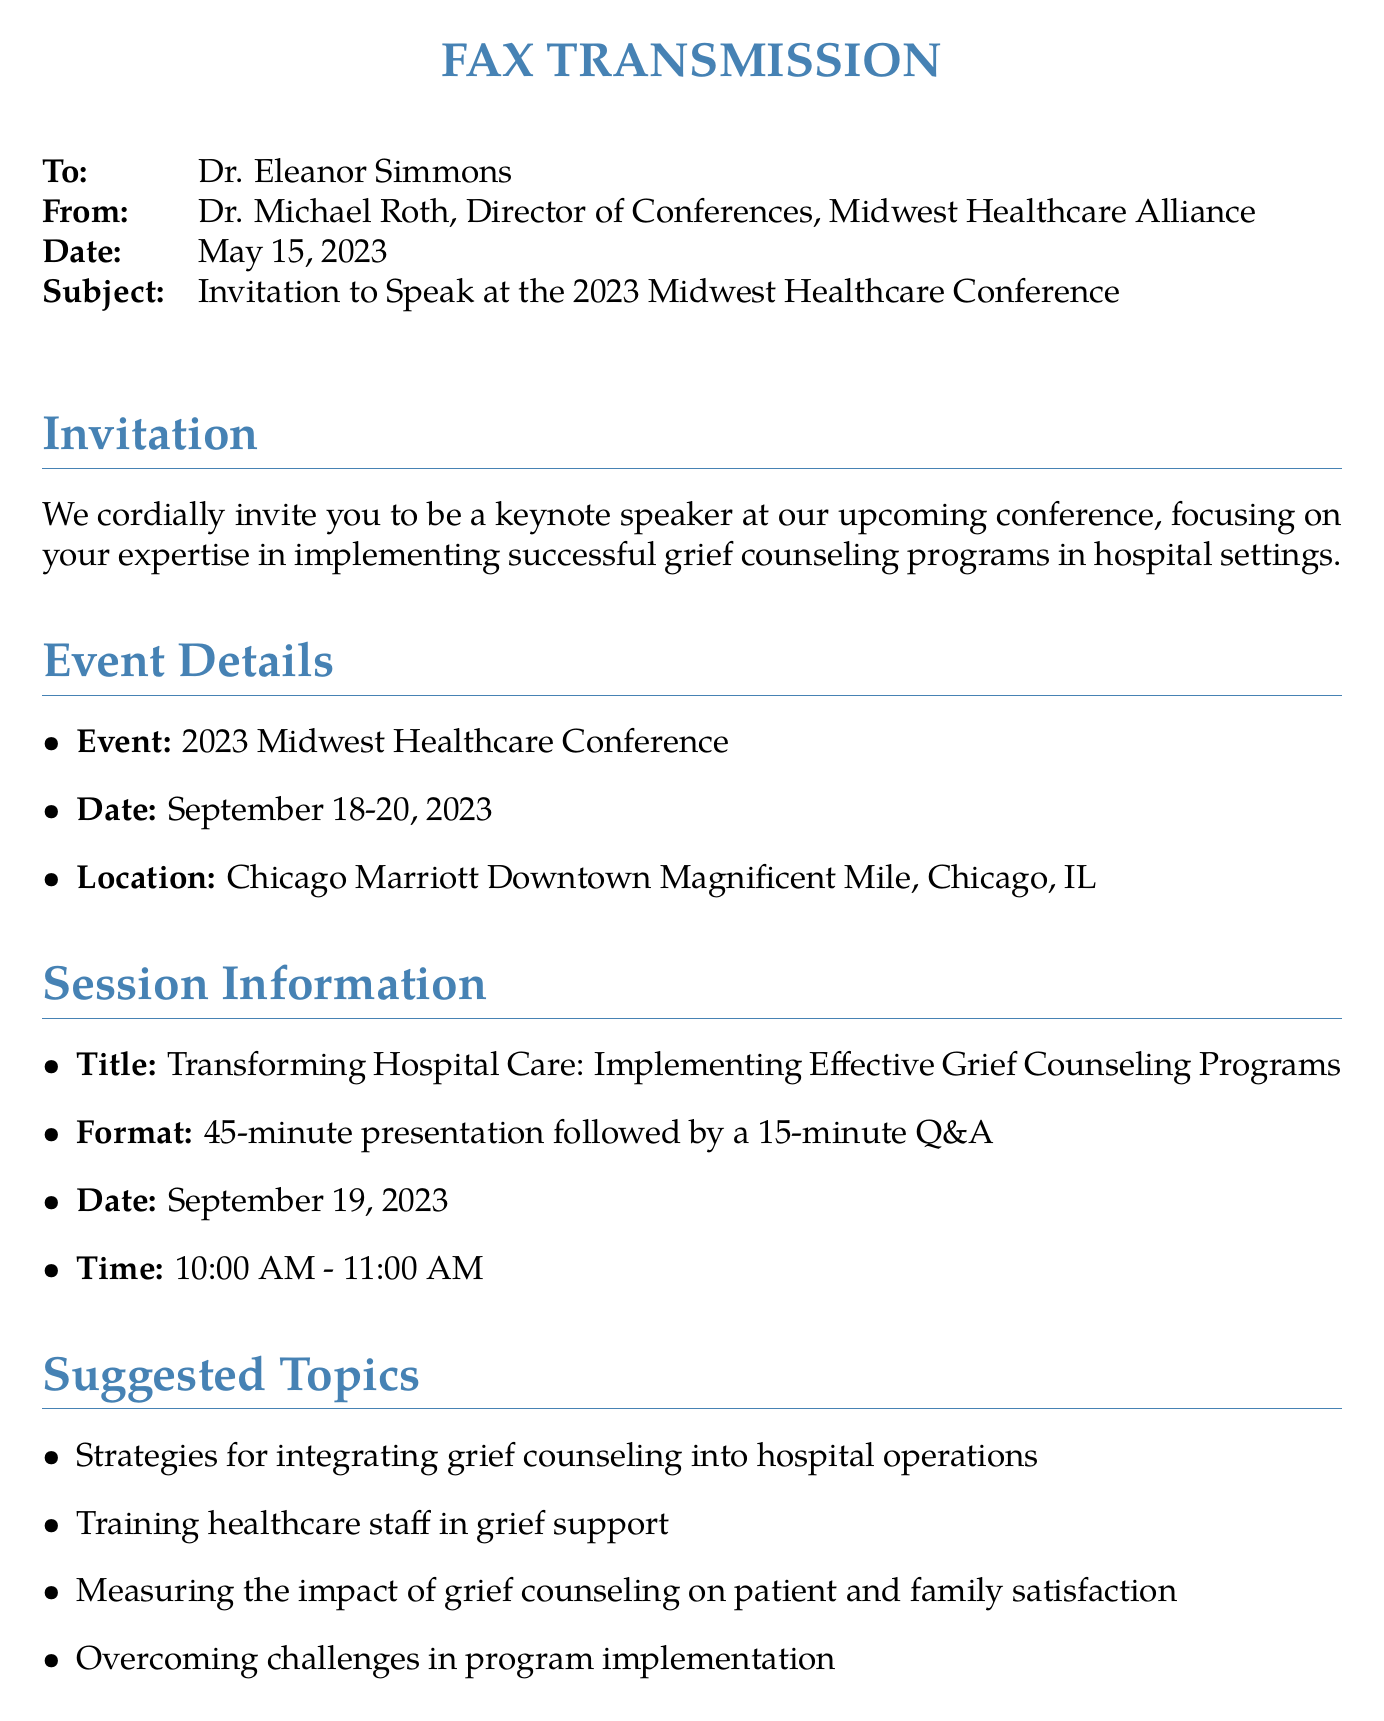What is the name of the conference? The conference is specified in the subject line of the fax as the "2023 Midwest Healthcare Conference."
Answer: 2023 Midwest Healthcare Conference Who is the invitee to the conference? The "To" section of the fax clearly states that Dr. Eleanor Simmons is the invitee.
Answer: Dr. Eleanor Simmons What are the conference dates? The date of the conference is mentioned in the event details section as September 18-20, 2023.
Answer: September 18-20, 2023 What is the title of the keynote presentation? The presentation title is clearly stated in the session information section as "Transforming Hospital Care: Implementing Effective Grief Counseling Programs."
Answer: Transforming Hospital Care: Implementing Effective Grief Counseling Programs How long is the presentation scheduled to last? The document specifies a 45-minute duration for the presentation followed by a Q&A, indicating the total time of the session.
Answer: 45 minutes What is one suggested topic for the presentation? The document lists suggested topics, one of which is "Strategies for integrating grief counseling into hospital operations."
Answer: Strategies for integrating grief counseling into hospital operations What benefits does the speaker receive? The benefits section outlines multiple advantages, one of which includes "Complimentary conference registration."
Answer: Complimentary conference registration When is the RSVP deadline? The response request section indicates the deadline for confirmation as June 1, 2023.
Answer: June 1, 2023 Who is the contact person for the conference? The fax provides the information about the conference coordinator, Sarah Johnson, in the response request section.
Answer: Sarah Johnson 